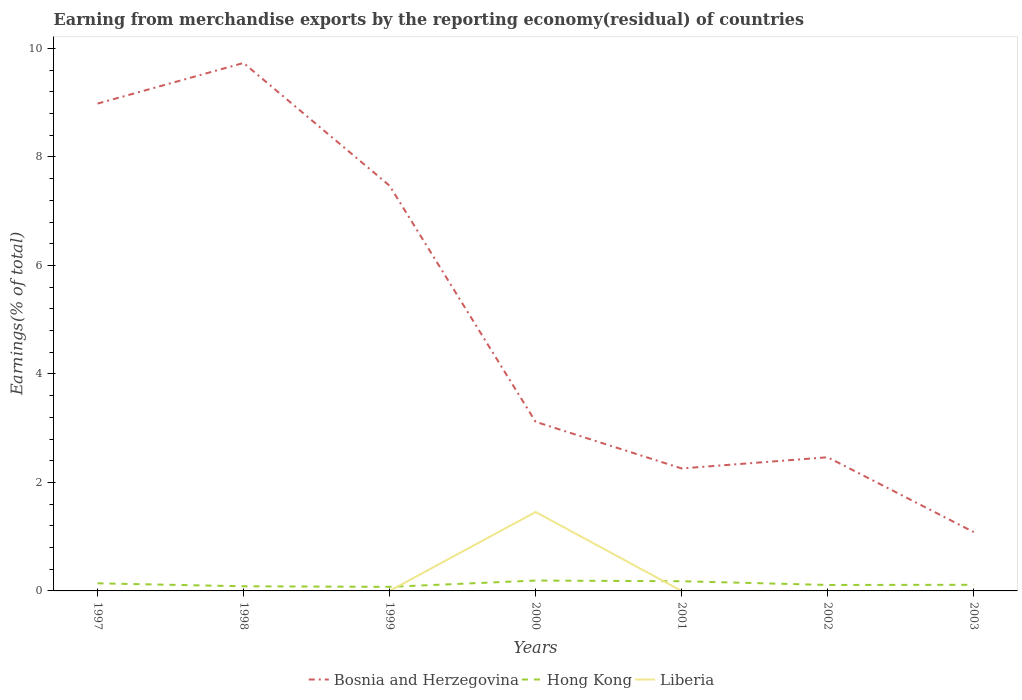Is the number of lines equal to the number of legend labels?
Your answer should be compact. No. Across all years, what is the maximum percentage of amount earned from merchandise exports in Bosnia and Herzegovina?
Your response must be concise. 1.08. What is the total percentage of amount earned from merchandise exports in Bosnia and Herzegovina in the graph?
Provide a succinct answer. 5.87. What is the difference between the highest and the second highest percentage of amount earned from merchandise exports in Bosnia and Herzegovina?
Offer a very short reply. 8.65. What is the difference between the highest and the lowest percentage of amount earned from merchandise exports in Bosnia and Herzegovina?
Provide a succinct answer. 3. Does the graph contain any zero values?
Your answer should be very brief. Yes. How many legend labels are there?
Provide a short and direct response. 3. What is the title of the graph?
Offer a very short reply. Earning from merchandise exports by the reporting economy(residual) of countries. Does "Lithuania" appear as one of the legend labels in the graph?
Make the answer very short. No. What is the label or title of the X-axis?
Give a very brief answer. Years. What is the label or title of the Y-axis?
Offer a very short reply. Earnings(% of total). What is the Earnings(% of total) in Bosnia and Herzegovina in 1997?
Provide a succinct answer. 8.98. What is the Earnings(% of total) in Hong Kong in 1997?
Provide a short and direct response. 0.14. What is the Earnings(% of total) of Liberia in 1997?
Offer a very short reply. 2.07381290602995e-9. What is the Earnings(% of total) in Bosnia and Herzegovina in 1998?
Give a very brief answer. 9.73. What is the Earnings(% of total) in Hong Kong in 1998?
Provide a succinct answer. 0.09. What is the Earnings(% of total) in Bosnia and Herzegovina in 1999?
Ensure brevity in your answer.  7.47. What is the Earnings(% of total) in Hong Kong in 1999?
Give a very brief answer. 0.08. What is the Earnings(% of total) of Liberia in 1999?
Your response must be concise. 2.00076381593646e-9. What is the Earnings(% of total) of Bosnia and Herzegovina in 2000?
Keep it short and to the point. 3.12. What is the Earnings(% of total) in Hong Kong in 2000?
Ensure brevity in your answer.  0.19. What is the Earnings(% of total) in Liberia in 2000?
Make the answer very short. 1.46. What is the Earnings(% of total) of Bosnia and Herzegovina in 2001?
Provide a short and direct response. 2.26. What is the Earnings(% of total) of Hong Kong in 2001?
Keep it short and to the point. 0.18. What is the Earnings(% of total) in Liberia in 2001?
Offer a very short reply. 7.442238297219409e-9. What is the Earnings(% of total) in Bosnia and Herzegovina in 2002?
Offer a very short reply. 2.46. What is the Earnings(% of total) of Hong Kong in 2002?
Ensure brevity in your answer.  0.11. What is the Earnings(% of total) of Bosnia and Herzegovina in 2003?
Provide a succinct answer. 1.08. What is the Earnings(% of total) in Hong Kong in 2003?
Offer a very short reply. 0.11. What is the Earnings(% of total) in Liberia in 2003?
Your answer should be compact. 9.89919850617748e-10. Across all years, what is the maximum Earnings(% of total) in Bosnia and Herzegovina?
Your response must be concise. 9.73. Across all years, what is the maximum Earnings(% of total) of Hong Kong?
Provide a succinct answer. 0.19. Across all years, what is the maximum Earnings(% of total) in Liberia?
Your answer should be compact. 1.46. Across all years, what is the minimum Earnings(% of total) in Bosnia and Herzegovina?
Offer a terse response. 1.08. Across all years, what is the minimum Earnings(% of total) of Hong Kong?
Offer a terse response. 0.08. Across all years, what is the minimum Earnings(% of total) in Liberia?
Keep it short and to the point. 0. What is the total Earnings(% of total) of Bosnia and Herzegovina in the graph?
Ensure brevity in your answer.  35.11. What is the total Earnings(% of total) in Hong Kong in the graph?
Provide a short and direct response. 0.89. What is the total Earnings(% of total) of Liberia in the graph?
Your answer should be very brief. 1.46. What is the difference between the Earnings(% of total) of Bosnia and Herzegovina in 1997 and that in 1998?
Keep it short and to the point. -0.75. What is the difference between the Earnings(% of total) in Hong Kong in 1997 and that in 1998?
Your answer should be compact. 0.05. What is the difference between the Earnings(% of total) in Bosnia and Herzegovina in 1997 and that in 1999?
Keep it short and to the point. 1.51. What is the difference between the Earnings(% of total) in Hong Kong in 1997 and that in 1999?
Provide a short and direct response. 0.07. What is the difference between the Earnings(% of total) in Liberia in 1997 and that in 1999?
Provide a short and direct response. 0. What is the difference between the Earnings(% of total) of Bosnia and Herzegovina in 1997 and that in 2000?
Keep it short and to the point. 5.87. What is the difference between the Earnings(% of total) in Hong Kong in 1997 and that in 2000?
Your response must be concise. -0.05. What is the difference between the Earnings(% of total) of Liberia in 1997 and that in 2000?
Your answer should be compact. -1.46. What is the difference between the Earnings(% of total) of Bosnia and Herzegovina in 1997 and that in 2001?
Keep it short and to the point. 6.73. What is the difference between the Earnings(% of total) of Hong Kong in 1997 and that in 2001?
Provide a succinct answer. -0.04. What is the difference between the Earnings(% of total) of Bosnia and Herzegovina in 1997 and that in 2002?
Your answer should be very brief. 6.52. What is the difference between the Earnings(% of total) in Hong Kong in 1997 and that in 2002?
Keep it short and to the point. 0.03. What is the difference between the Earnings(% of total) of Bosnia and Herzegovina in 1997 and that in 2003?
Provide a succinct answer. 7.9. What is the difference between the Earnings(% of total) of Hong Kong in 1997 and that in 2003?
Ensure brevity in your answer.  0.03. What is the difference between the Earnings(% of total) of Liberia in 1997 and that in 2003?
Provide a short and direct response. 0. What is the difference between the Earnings(% of total) of Bosnia and Herzegovina in 1998 and that in 1999?
Ensure brevity in your answer.  2.26. What is the difference between the Earnings(% of total) of Hong Kong in 1998 and that in 1999?
Give a very brief answer. 0.01. What is the difference between the Earnings(% of total) of Bosnia and Herzegovina in 1998 and that in 2000?
Make the answer very short. 6.62. What is the difference between the Earnings(% of total) in Hong Kong in 1998 and that in 2000?
Offer a very short reply. -0.11. What is the difference between the Earnings(% of total) in Bosnia and Herzegovina in 1998 and that in 2001?
Provide a succinct answer. 7.47. What is the difference between the Earnings(% of total) in Hong Kong in 1998 and that in 2001?
Your response must be concise. -0.09. What is the difference between the Earnings(% of total) in Bosnia and Herzegovina in 1998 and that in 2002?
Keep it short and to the point. 7.27. What is the difference between the Earnings(% of total) of Hong Kong in 1998 and that in 2002?
Your answer should be very brief. -0.02. What is the difference between the Earnings(% of total) of Bosnia and Herzegovina in 1998 and that in 2003?
Give a very brief answer. 8.65. What is the difference between the Earnings(% of total) of Hong Kong in 1998 and that in 2003?
Offer a terse response. -0.03. What is the difference between the Earnings(% of total) in Bosnia and Herzegovina in 1999 and that in 2000?
Give a very brief answer. 4.35. What is the difference between the Earnings(% of total) of Hong Kong in 1999 and that in 2000?
Ensure brevity in your answer.  -0.12. What is the difference between the Earnings(% of total) in Liberia in 1999 and that in 2000?
Provide a short and direct response. -1.46. What is the difference between the Earnings(% of total) of Bosnia and Herzegovina in 1999 and that in 2001?
Your answer should be compact. 5.21. What is the difference between the Earnings(% of total) in Hong Kong in 1999 and that in 2001?
Your response must be concise. -0.1. What is the difference between the Earnings(% of total) in Liberia in 1999 and that in 2001?
Provide a short and direct response. -0. What is the difference between the Earnings(% of total) of Bosnia and Herzegovina in 1999 and that in 2002?
Keep it short and to the point. 5.01. What is the difference between the Earnings(% of total) of Hong Kong in 1999 and that in 2002?
Keep it short and to the point. -0.03. What is the difference between the Earnings(% of total) in Bosnia and Herzegovina in 1999 and that in 2003?
Offer a terse response. 6.38. What is the difference between the Earnings(% of total) of Hong Kong in 1999 and that in 2003?
Your answer should be compact. -0.04. What is the difference between the Earnings(% of total) in Bosnia and Herzegovina in 2000 and that in 2001?
Make the answer very short. 0.86. What is the difference between the Earnings(% of total) in Hong Kong in 2000 and that in 2001?
Your answer should be very brief. 0.01. What is the difference between the Earnings(% of total) of Liberia in 2000 and that in 2001?
Your answer should be compact. 1.46. What is the difference between the Earnings(% of total) of Bosnia and Herzegovina in 2000 and that in 2002?
Your answer should be compact. 0.65. What is the difference between the Earnings(% of total) in Hong Kong in 2000 and that in 2002?
Make the answer very short. 0.08. What is the difference between the Earnings(% of total) of Bosnia and Herzegovina in 2000 and that in 2003?
Your answer should be compact. 2.03. What is the difference between the Earnings(% of total) in Hong Kong in 2000 and that in 2003?
Your response must be concise. 0.08. What is the difference between the Earnings(% of total) in Liberia in 2000 and that in 2003?
Keep it short and to the point. 1.46. What is the difference between the Earnings(% of total) of Bosnia and Herzegovina in 2001 and that in 2002?
Offer a terse response. -0.21. What is the difference between the Earnings(% of total) of Hong Kong in 2001 and that in 2002?
Your answer should be compact. 0.07. What is the difference between the Earnings(% of total) of Bosnia and Herzegovina in 2001 and that in 2003?
Your answer should be very brief. 1.17. What is the difference between the Earnings(% of total) of Hong Kong in 2001 and that in 2003?
Make the answer very short. 0.07. What is the difference between the Earnings(% of total) of Liberia in 2001 and that in 2003?
Your response must be concise. 0. What is the difference between the Earnings(% of total) in Bosnia and Herzegovina in 2002 and that in 2003?
Provide a succinct answer. 1.38. What is the difference between the Earnings(% of total) in Hong Kong in 2002 and that in 2003?
Your answer should be compact. -0. What is the difference between the Earnings(% of total) in Bosnia and Herzegovina in 1997 and the Earnings(% of total) in Hong Kong in 1998?
Provide a succinct answer. 8.9. What is the difference between the Earnings(% of total) of Bosnia and Herzegovina in 1997 and the Earnings(% of total) of Hong Kong in 1999?
Keep it short and to the point. 8.91. What is the difference between the Earnings(% of total) of Bosnia and Herzegovina in 1997 and the Earnings(% of total) of Liberia in 1999?
Give a very brief answer. 8.98. What is the difference between the Earnings(% of total) of Hong Kong in 1997 and the Earnings(% of total) of Liberia in 1999?
Provide a short and direct response. 0.14. What is the difference between the Earnings(% of total) of Bosnia and Herzegovina in 1997 and the Earnings(% of total) of Hong Kong in 2000?
Offer a very short reply. 8.79. What is the difference between the Earnings(% of total) of Bosnia and Herzegovina in 1997 and the Earnings(% of total) of Liberia in 2000?
Offer a very short reply. 7.53. What is the difference between the Earnings(% of total) in Hong Kong in 1997 and the Earnings(% of total) in Liberia in 2000?
Offer a terse response. -1.31. What is the difference between the Earnings(% of total) of Bosnia and Herzegovina in 1997 and the Earnings(% of total) of Hong Kong in 2001?
Provide a short and direct response. 8.8. What is the difference between the Earnings(% of total) of Bosnia and Herzegovina in 1997 and the Earnings(% of total) of Liberia in 2001?
Your response must be concise. 8.98. What is the difference between the Earnings(% of total) of Hong Kong in 1997 and the Earnings(% of total) of Liberia in 2001?
Your response must be concise. 0.14. What is the difference between the Earnings(% of total) of Bosnia and Herzegovina in 1997 and the Earnings(% of total) of Hong Kong in 2002?
Provide a short and direct response. 8.87. What is the difference between the Earnings(% of total) of Bosnia and Herzegovina in 1997 and the Earnings(% of total) of Hong Kong in 2003?
Provide a short and direct response. 8.87. What is the difference between the Earnings(% of total) of Bosnia and Herzegovina in 1997 and the Earnings(% of total) of Liberia in 2003?
Give a very brief answer. 8.98. What is the difference between the Earnings(% of total) of Hong Kong in 1997 and the Earnings(% of total) of Liberia in 2003?
Offer a very short reply. 0.14. What is the difference between the Earnings(% of total) in Bosnia and Herzegovina in 1998 and the Earnings(% of total) in Hong Kong in 1999?
Ensure brevity in your answer.  9.66. What is the difference between the Earnings(% of total) of Bosnia and Herzegovina in 1998 and the Earnings(% of total) of Liberia in 1999?
Keep it short and to the point. 9.73. What is the difference between the Earnings(% of total) of Hong Kong in 1998 and the Earnings(% of total) of Liberia in 1999?
Provide a short and direct response. 0.09. What is the difference between the Earnings(% of total) in Bosnia and Herzegovina in 1998 and the Earnings(% of total) in Hong Kong in 2000?
Your answer should be very brief. 9.54. What is the difference between the Earnings(% of total) in Bosnia and Herzegovina in 1998 and the Earnings(% of total) in Liberia in 2000?
Offer a terse response. 8.28. What is the difference between the Earnings(% of total) of Hong Kong in 1998 and the Earnings(% of total) of Liberia in 2000?
Offer a very short reply. -1.37. What is the difference between the Earnings(% of total) in Bosnia and Herzegovina in 1998 and the Earnings(% of total) in Hong Kong in 2001?
Your answer should be compact. 9.55. What is the difference between the Earnings(% of total) in Bosnia and Herzegovina in 1998 and the Earnings(% of total) in Liberia in 2001?
Make the answer very short. 9.73. What is the difference between the Earnings(% of total) in Hong Kong in 1998 and the Earnings(% of total) in Liberia in 2001?
Keep it short and to the point. 0.09. What is the difference between the Earnings(% of total) of Bosnia and Herzegovina in 1998 and the Earnings(% of total) of Hong Kong in 2002?
Your response must be concise. 9.62. What is the difference between the Earnings(% of total) in Bosnia and Herzegovina in 1998 and the Earnings(% of total) in Hong Kong in 2003?
Your answer should be compact. 9.62. What is the difference between the Earnings(% of total) of Bosnia and Herzegovina in 1998 and the Earnings(% of total) of Liberia in 2003?
Provide a short and direct response. 9.73. What is the difference between the Earnings(% of total) of Hong Kong in 1998 and the Earnings(% of total) of Liberia in 2003?
Provide a short and direct response. 0.09. What is the difference between the Earnings(% of total) of Bosnia and Herzegovina in 1999 and the Earnings(% of total) of Hong Kong in 2000?
Keep it short and to the point. 7.28. What is the difference between the Earnings(% of total) in Bosnia and Herzegovina in 1999 and the Earnings(% of total) in Liberia in 2000?
Provide a succinct answer. 6.01. What is the difference between the Earnings(% of total) in Hong Kong in 1999 and the Earnings(% of total) in Liberia in 2000?
Offer a terse response. -1.38. What is the difference between the Earnings(% of total) in Bosnia and Herzegovina in 1999 and the Earnings(% of total) in Hong Kong in 2001?
Your answer should be very brief. 7.29. What is the difference between the Earnings(% of total) of Bosnia and Herzegovina in 1999 and the Earnings(% of total) of Liberia in 2001?
Your answer should be very brief. 7.47. What is the difference between the Earnings(% of total) of Hong Kong in 1999 and the Earnings(% of total) of Liberia in 2001?
Provide a succinct answer. 0.08. What is the difference between the Earnings(% of total) in Bosnia and Herzegovina in 1999 and the Earnings(% of total) in Hong Kong in 2002?
Provide a succinct answer. 7.36. What is the difference between the Earnings(% of total) in Bosnia and Herzegovina in 1999 and the Earnings(% of total) in Hong Kong in 2003?
Give a very brief answer. 7.36. What is the difference between the Earnings(% of total) in Bosnia and Herzegovina in 1999 and the Earnings(% of total) in Liberia in 2003?
Provide a short and direct response. 7.47. What is the difference between the Earnings(% of total) in Hong Kong in 1999 and the Earnings(% of total) in Liberia in 2003?
Ensure brevity in your answer.  0.08. What is the difference between the Earnings(% of total) of Bosnia and Herzegovina in 2000 and the Earnings(% of total) of Hong Kong in 2001?
Provide a short and direct response. 2.94. What is the difference between the Earnings(% of total) in Bosnia and Herzegovina in 2000 and the Earnings(% of total) in Liberia in 2001?
Provide a short and direct response. 3.12. What is the difference between the Earnings(% of total) of Hong Kong in 2000 and the Earnings(% of total) of Liberia in 2001?
Keep it short and to the point. 0.19. What is the difference between the Earnings(% of total) of Bosnia and Herzegovina in 2000 and the Earnings(% of total) of Hong Kong in 2002?
Provide a succinct answer. 3.01. What is the difference between the Earnings(% of total) of Bosnia and Herzegovina in 2000 and the Earnings(% of total) of Hong Kong in 2003?
Your answer should be compact. 3. What is the difference between the Earnings(% of total) of Bosnia and Herzegovina in 2000 and the Earnings(% of total) of Liberia in 2003?
Your answer should be compact. 3.12. What is the difference between the Earnings(% of total) of Hong Kong in 2000 and the Earnings(% of total) of Liberia in 2003?
Give a very brief answer. 0.19. What is the difference between the Earnings(% of total) of Bosnia and Herzegovina in 2001 and the Earnings(% of total) of Hong Kong in 2002?
Ensure brevity in your answer.  2.15. What is the difference between the Earnings(% of total) of Bosnia and Herzegovina in 2001 and the Earnings(% of total) of Hong Kong in 2003?
Offer a terse response. 2.15. What is the difference between the Earnings(% of total) in Bosnia and Herzegovina in 2001 and the Earnings(% of total) in Liberia in 2003?
Offer a terse response. 2.26. What is the difference between the Earnings(% of total) in Hong Kong in 2001 and the Earnings(% of total) in Liberia in 2003?
Make the answer very short. 0.18. What is the difference between the Earnings(% of total) in Bosnia and Herzegovina in 2002 and the Earnings(% of total) in Hong Kong in 2003?
Your answer should be very brief. 2.35. What is the difference between the Earnings(% of total) of Bosnia and Herzegovina in 2002 and the Earnings(% of total) of Liberia in 2003?
Offer a very short reply. 2.46. What is the difference between the Earnings(% of total) in Hong Kong in 2002 and the Earnings(% of total) in Liberia in 2003?
Your response must be concise. 0.11. What is the average Earnings(% of total) of Bosnia and Herzegovina per year?
Ensure brevity in your answer.  5.02. What is the average Earnings(% of total) of Hong Kong per year?
Your answer should be compact. 0.13. What is the average Earnings(% of total) of Liberia per year?
Your answer should be compact. 0.21. In the year 1997, what is the difference between the Earnings(% of total) of Bosnia and Herzegovina and Earnings(% of total) of Hong Kong?
Provide a succinct answer. 8.84. In the year 1997, what is the difference between the Earnings(% of total) of Bosnia and Herzegovina and Earnings(% of total) of Liberia?
Make the answer very short. 8.98. In the year 1997, what is the difference between the Earnings(% of total) in Hong Kong and Earnings(% of total) in Liberia?
Your response must be concise. 0.14. In the year 1998, what is the difference between the Earnings(% of total) in Bosnia and Herzegovina and Earnings(% of total) in Hong Kong?
Provide a succinct answer. 9.65. In the year 1999, what is the difference between the Earnings(% of total) of Bosnia and Herzegovina and Earnings(% of total) of Hong Kong?
Your answer should be compact. 7.39. In the year 1999, what is the difference between the Earnings(% of total) in Bosnia and Herzegovina and Earnings(% of total) in Liberia?
Your answer should be compact. 7.47. In the year 1999, what is the difference between the Earnings(% of total) in Hong Kong and Earnings(% of total) in Liberia?
Make the answer very short. 0.08. In the year 2000, what is the difference between the Earnings(% of total) of Bosnia and Herzegovina and Earnings(% of total) of Hong Kong?
Your answer should be very brief. 2.93. In the year 2000, what is the difference between the Earnings(% of total) in Bosnia and Herzegovina and Earnings(% of total) in Liberia?
Ensure brevity in your answer.  1.66. In the year 2000, what is the difference between the Earnings(% of total) in Hong Kong and Earnings(% of total) in Liberia?
Keep it short and to the point. -1.26. In the year 2001, what is the difference between the Earnings(% of total) of Bosnia and Herzegovina and Earnings(% of total) of Hong Kong?
Offer a terse response. 2.08. In the year 2001, what is the difference between the Earnings(% of total) in Bosnia and Herzegovina and Earnings(% of total) in Liberia?
Give a very brief answer. 2.26. In the year 2001, what is the difference between the Earnings(% of total) in Hong Kong and Earnings(% of total) in Liberia?
Give a very brief answer. 0.18. In the year 2002, what is the difference between the Earnings(% of total) in Bosnia and Herzegovina and Earnings(% of total) in Hong Kong?
Make the answer very short. 2.35. In the year 2003, what is the difference between the Earnings(% of total) in Bosnia and Herzegovina and Earnings(% of total) in Hong Kong?
Provide a succinct answer. 0.97. In the year 2003, what is the difference between the Earnings(% of total) of Bosnia and Herzegovina and Earnings(% of total) of Liberia?
Provide a succinct answer. 1.08. In the year 2003, what is the difference between the Earnings(% of total) in Hong Kong and Earnings(% of total) in Liberia?
Ensure brevity in your answer.  0.11. What is the ratio of the Earnings(% of total) of Bosnia and Herzegovina in 1997 to that in 1998?
Make the answer very short. 0.92. What is the ratio of the Earnings(% of total) in Hong Kong in 1997 to that in 1998?
Offer a very short reply. 1.64. What is the ratio of the Earnings(% of total) in Bosnia and Herzegovina in 1997 to that in 1999?
Ensure brevity in your answer.  1.2. What is the ratio of the Earnings(% of total) in Hong Kong in 1997 to that in 1999?
Offer a very short reply. 1.87. What is the ratio of the Earnings(% of total) of Liberia in 1997 to that in 1999?
Ensure brevity in your answer.  1.04. What is the ratio of the Earnings(% of total) in Bosnia and Herzegovina in 1997 to that in 2000?
Provide a succinct answer. 2.88. What is the ratio of the Earnings(% of total) of Hong Kong in 1997 to that in 2000?
Ensure brevity in your answer.  0.73. What is the ratio of the Earnings(% of total) of Liberia in 1997 to that in 2000?
Offer a very short reply. 0. What is the ratio of the Earnings(% of total) in Bosnia and Herzegovina in 1997 to that in 2001?
Keep it short and to the point. 3.98. What is the ratio of the Earnings(% of total) of Hong Kong in 1997 to that in 2001?
Your answer should be very brief. 0.79. What is the ratio of the Earnings(% of total) in Liberia in 1997 to that in 2001?
Your response must be concise. 0.28. What is the ratio of the Earnings(% of total) of Bosnia and Herzegovina in 1997 to that in 2002?
Ensure brevity in your answer.  3.65. What is the ratio of the Earnings(% of total) of Hong Kong in 1997 to that in 2002?
Provide a succinct answer. 1.28. What is the ratio of the Earnings(% of total) in Bosnia and Herzegovina in 1997 to that in 2003?
Your response must be concise. 8.28. What is the ratio of the Earnings(% of total) of Hong Kong in 1997 to that in 2003?
Ensure brevity in your answer.  1.24. What is the ratio of the Earnings(% of total) of Liberia in 1997 to that in 2003?
Offer a very short reply. 2.09. What is the ratio of the Earnings(% of total) in Bosnia and Herzegovina in 1998 to that in 1999?
Your answer should be very brief. 1.3. What is the ratio of the Earnings(% of total) of Hong Kong in 1998 to that in 1999?
Your answer should be compact. 1.14. What is the ratio of the Earnings(% of total) in Bosnia and Herzegovina in 1998 to that in 2000?
Ensure brevity in your answer.  3.12. What is the ratio of the Earnings(% of total) of Hong Kong in 1998 to that in 2000?
Your response must be concise. 0.45. What is the ratio of the Earnings(% of total) of Bosnia and Herzegovina in 1998 to that in 2001?
Make the answer very short. 4.31. What is the ratio of the Earnings(% of total) in Hong Kong in 1998 to that in 2001?
Ensure brevity in your answer.  0.48. What is the ratio of the Earnings(% of total) of Bosnia and Herzegovina in 1998 to that in 2002?
Provide a succinct answer. 3.95. What is the ratio of the Earnings(% of total) of Hong Kong in 1998 to that in 2002?
Your answer should be very brief. 0.78. What is the ratio of the Earnings(% of total) of Bosnia and Herzegovina in 1998 to that in 2003?
Your answer should be compact. 8.97. What is the ratio of the Earnings(% of total) in Hong Kong in 1998 to that in 2003?
Provide a succinct answer. 0.76. What is the ratio of the Earnings(% of total) of Bosnia and Herzegovina in 1999 to that in 2000?
Offer a terse response. 2.4. What is the ratio of the Earnings(% of total) of Hong Kong in 1999 to that in 2000?
Ensure brevity in your answer.  0.39. What is the ratio of the Earnings(% of total) in Bosnia and Herzegovina in 1999 to that in 2001?
Keep it short and to the point. 3.31. What is the ratio of the Earnings(% of total) of Hong Kong in 1999 to that in 2001?
Provide a succinct answer. 0.42. What is the ratio of the Earnings(% of total) of Liberia in 1999 to that in 2001?
Keep it short and to the point. 0.27. What is the ratio of the Earnings(% of total) of Bosnia and Herzegovina in 1999 to that in 2002?
Your answer should be very brief. 3.03. What is the ratio of the Earnings(% of total) of Hong Kong in 1999 to that in 2002?
Your answer should be very brief. 0.68. What is the ratio of the Earnings(% of total) of Bosnia and Herzegovina in 1999 to that in 2003?
Ensure brevity in your answer.  6.89. What is the ratio of the Earnings(% of total) in Hong Kong in 1999 to that in 2003?
Your response must be concise. 0.67. What is the ratio of the Earnings(% of total) in Liberia in 1999 to that in 2003?
Your answer should be very brief. 2.02. What is the ratio of the Earnings(% of total) in Bosnia and Herzegovina in 2000 to that in 2001?
Make the answer very short. 1.38. What is the ratio of the Earnings(% of total) in Hong Kong in 2000 to that in 2001?
Ensure brevity in your answer.  1.07. What is the ratio of the Earnings(% of total) in Liberia in 2000 to that in 2001?
Give a very brief answer. 1.96e+08. What is the ratio of the Earnings(% of total) in Bosnia and Herzegovina in 2000 to that in 2002?
Keep it short and to the point. 1.27. What is the ratio of the Earnings(% of total) in Hong Kong in 2000 to that in 2002?
Give a very brief answer. 1.74. What is the ratio of the Earnings(% of total) of Bosnia and Herzegovina in 2000 to that in 2003?
Ensure brevity in your answer.  2.87. What is the ratio of the Earnings(% of total) of Hong Kong in 2000 to that in 2003?
Offer a very short reply. 1.69. What is the ratio of the Earnings(% of total) in Liberia in 2000 to that in 2003?
Your answer should be very brief. 1.47e+09. What is the ratio of the Earnings(% of total) in Bosnia and Herzegovina in 2001 to that in 2002?
Your response must be concise. 0.92. What is the ratio of the Earnings(% of total) of Hong Kong in 2001 to that in 2002?
Your answer should be very brief. 1.63. What is the ratio of the Earnings(% of total) of Bosnia and Herzegovina in 2001 to that in 2003?
Provide a short and direct response. 2.08. What is the ratio of the Earnings(% of total) in Hong Kong in 2001 to that in 2003?
Your answer should be very brief. 1.58. What is the ratio of the Earnings(% of total) in Liberia in 2001 to that in 2003?
Give a very brief answer. 7.52. What is the ratio of the Earnings(% of total) of Bosnia and Herzegovina in 2002 to that in 2003?
Keep it short and to the point. 2.27. What is the ratio of the Earnings(% of total) in Hong Kong in 2002 to that in 2003?
Your answer should be compact. 0.97. What is the difference between the highest and the second highest Earnings(% of total) in Bosnia and Herzegovina?
Offer a terse response. 0.75. What is the difference between the highest and the second highest Earnings(% of total) in Hong Kong?
Make the answer very short. 0.01. What is the difference between the highest and the second highest Earnings(% of total) in Liberia?
Provide a succinct answer. 1.46. What is the difference between the highest and the lowest Earnings(% of total) in Bosnia and Herzegovina?
Your answer should be very brief. 8.65. What is the difference between the highest and the lowest Earnings(% of total) of Hong Kong?
Offer a terse response. 0.12. What is the difference between the highest and the lowest Earnings(% of total) in Liberia?
Make the answer very short. 1.46. 